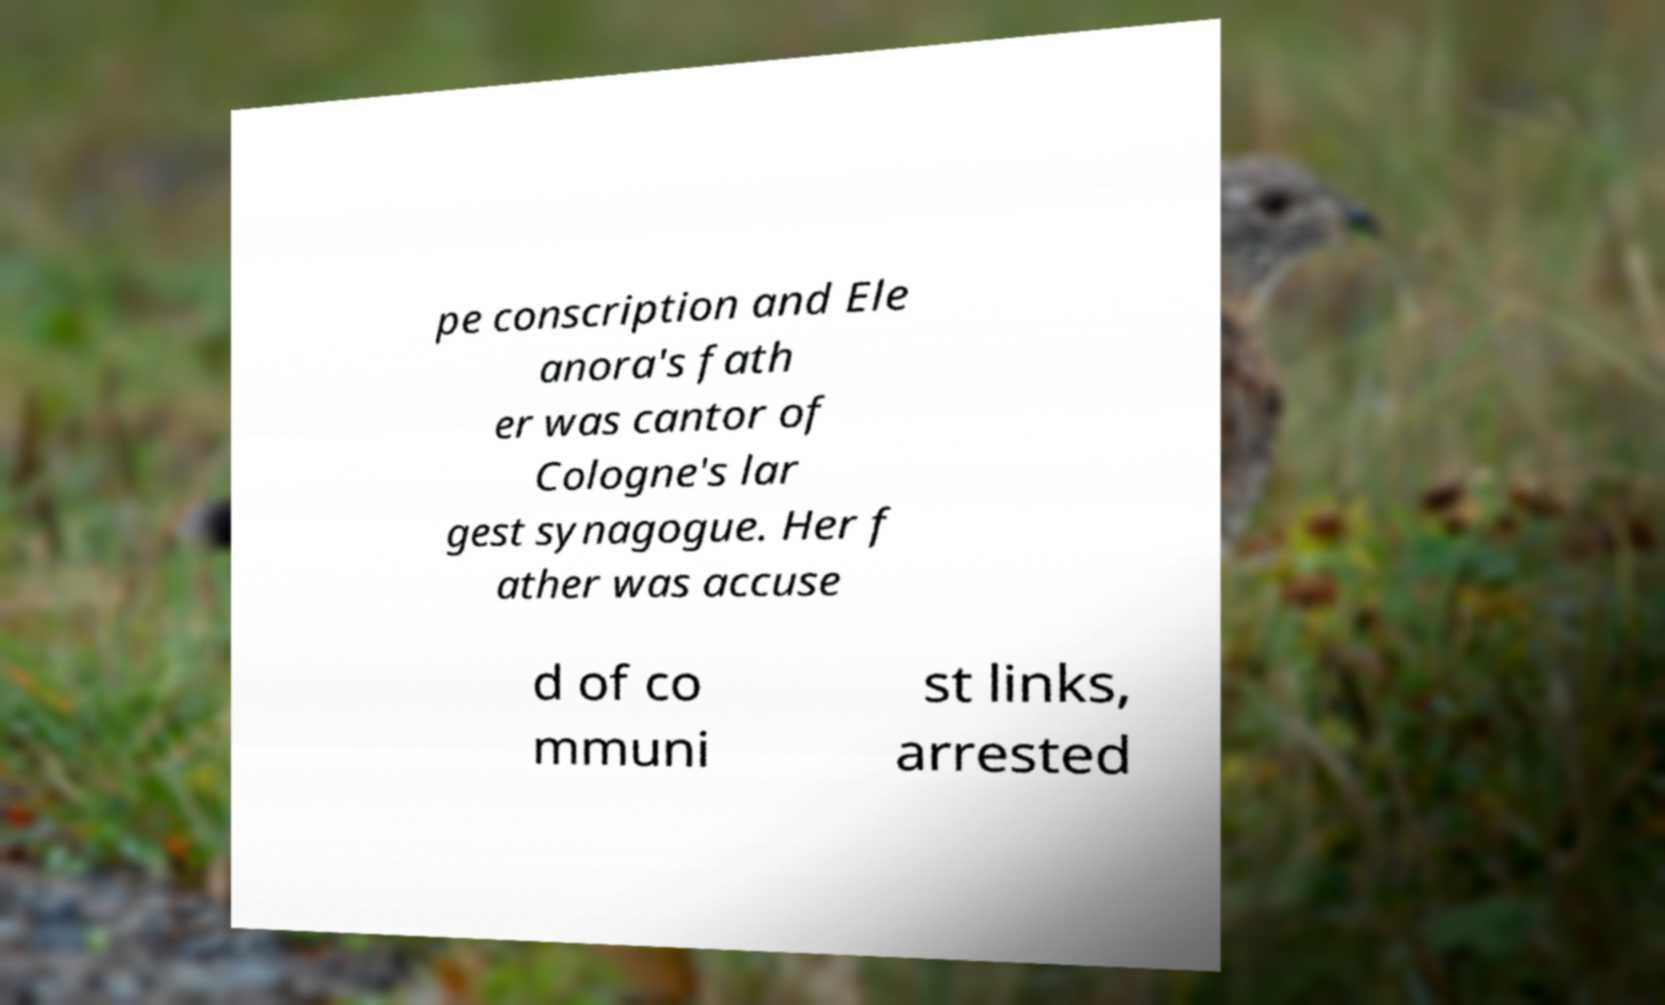What messages or text are displayed in this image? I need them in a readable, typed format. pe conscription and Ele anora's fath er was cantor of Cologne's lar gest synagogue. Her f ather was accuse d of co mmuni st links, arrested 